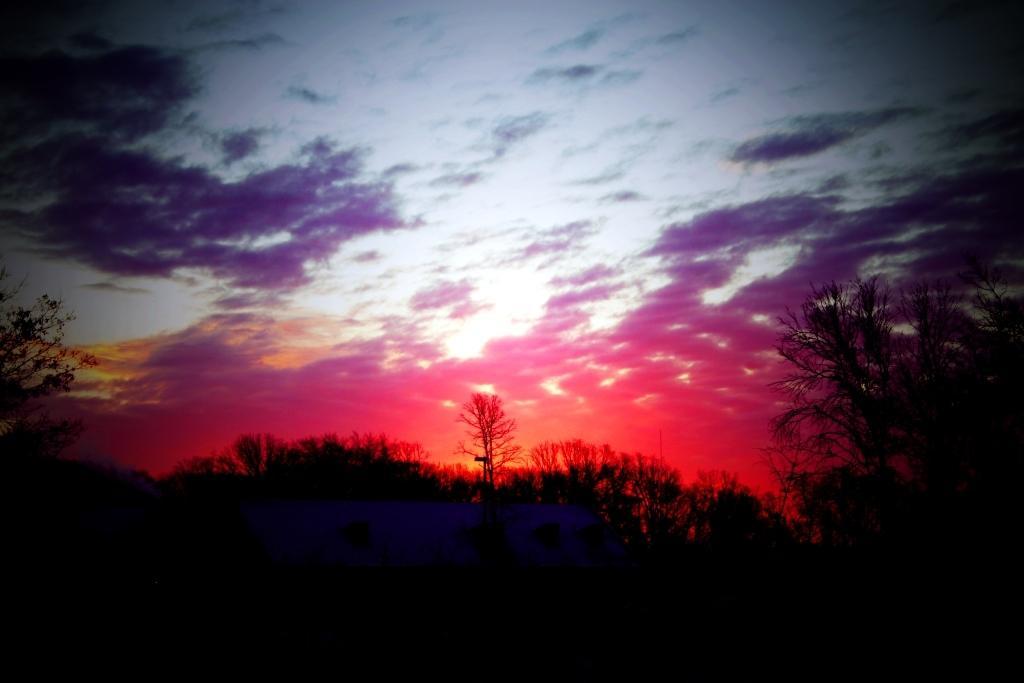How would you summarize this image in a sentence or two? In this image we can see some trees and at the top we can see the sky with clouds. 